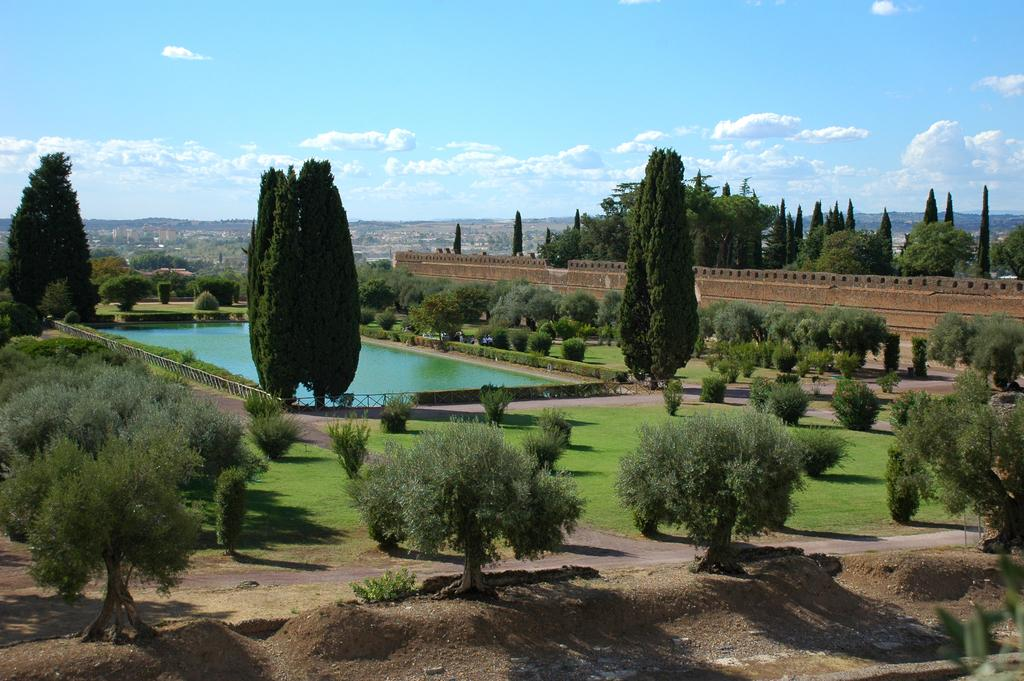What type of natural elements are present in the image? There are many trees and plants in the image. What can be seen in the middle of the image? There is water in the middle of the image. What is located on the right side of the image? There is a wall on the right side of the image. What is visible in the sky at the top of the image? There are clouds visible in the sky at the top of the image. What type of metal is being used to hold the mother's finger in the image? There is no mother or finger present in the image, and therefore no metal is being used to hold them. 